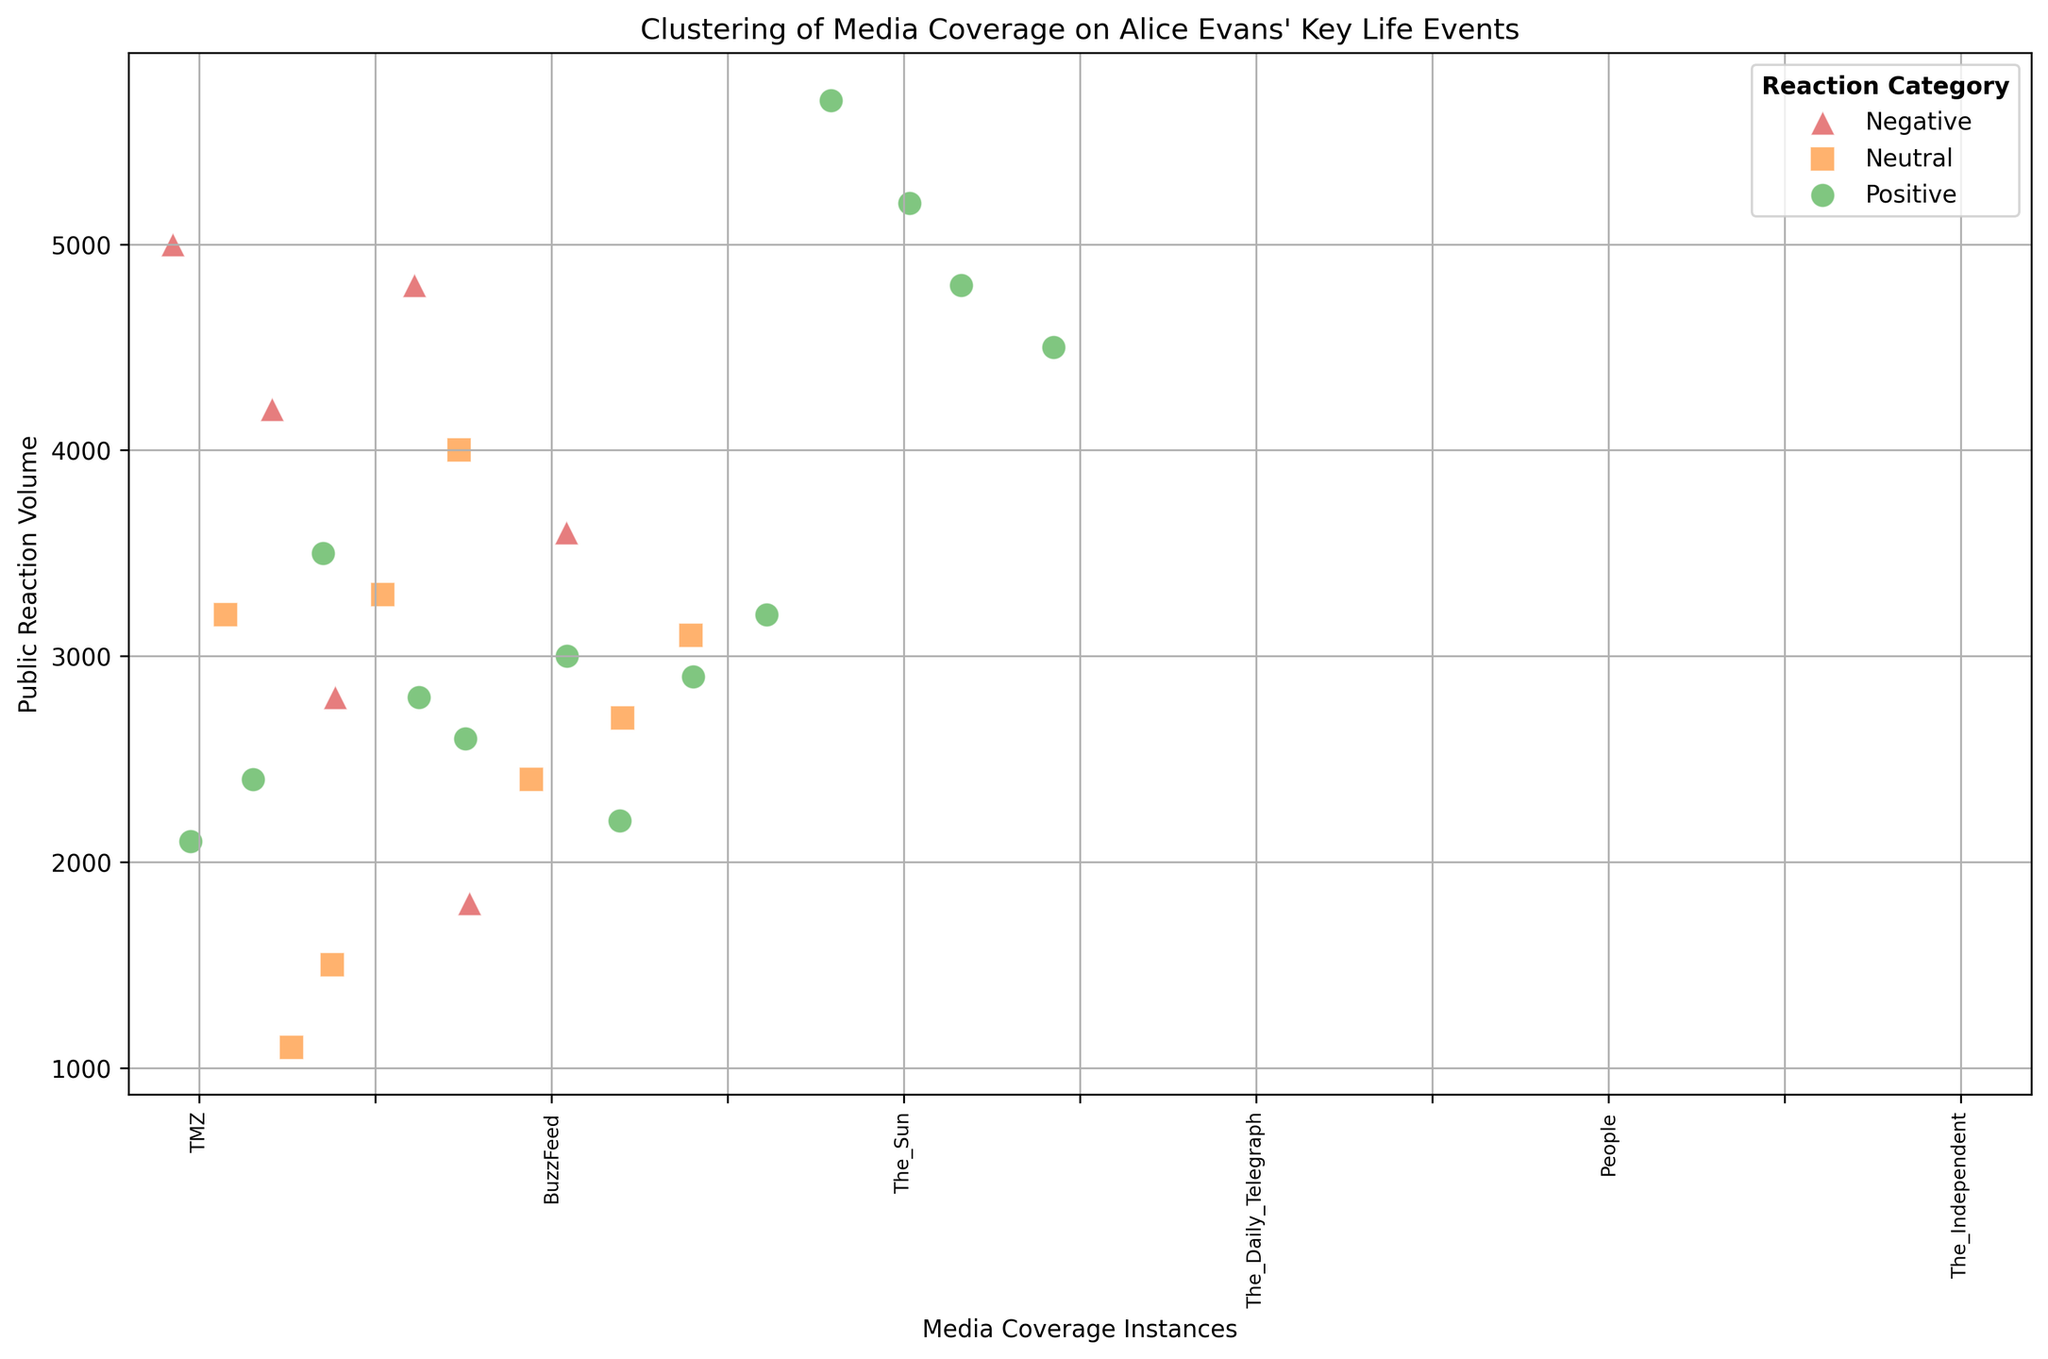What is the public reaction volume for the media outlets covering the "Interview on Lorraine" event? Look for data points related to the "Interview on Lorraine" event, noting their public reaction volumes: The Mirror (3500), Express (2800), HuffPost (1500)
Answer: 3500, 2800, 1500 Which media outlet had the highest public reaction volume for a positive reaction category? Examine the data points with positive reaction categories and compare their public reaction volumes. The highest is for the "Participation in MeToo Campaign" by The New York Times (5700)
Answer: The New York Times When comparing the “Breakup with Ioan Gruffudd” and “Custody Battle with Ioan Gruffudd” events, which one generated more negative public reactions overall? Sum the negative public reaction volumes for each event. "Breakup with Ioan Gruffudd": TMZ (5000) + Daily Mail (4200) + Just Jared (2800) = 12000. "Custody Battle with Ioan Gruffudd": The Sun (4800) = 4800
Answer: Breakup with Ioan Gruffudd What is the total public reaction volume for neutral reactions across all events? Sum the public reaction volumes for all neutral reactions: People (3200) + The Sun (1100) + HuffPost (1500) + The Guardian (3300) + BBC (4000) + HuffPost (2400) + BuzzFeed (2700) + The Sun (3100) = 21300
Answer: 21300 Which media outlet covered the most events? Count how many times each media outlet appears. "The Sun" appears 3 times (Instagram Post on Breakup, Instagram Announcements, Custody Battle with Ioan Gruffudd), which is the highest.
Answer: The Sun What is the average public reaction volume for positive reactions? Sum the public reaction volumes for all positive reactions: 2100 + 2400 + 3500 + 2800 + 2600 + 3000 + 2200 + 2900 + 3200 + 5700 + 5200 + 4800 + 4500 = 44800, and divide by the number of positive reactions: 44800 / 13 ≈ 3446.15
Answer: 3446.15 Which event had the highest public reaction volume regardless of reaction category? Compare the public reaction volumes of all events listed. The highest is 5700 for "Participation in MeToo Campaign" by The New York Times
Answer: Participation in MeToo Campaign 